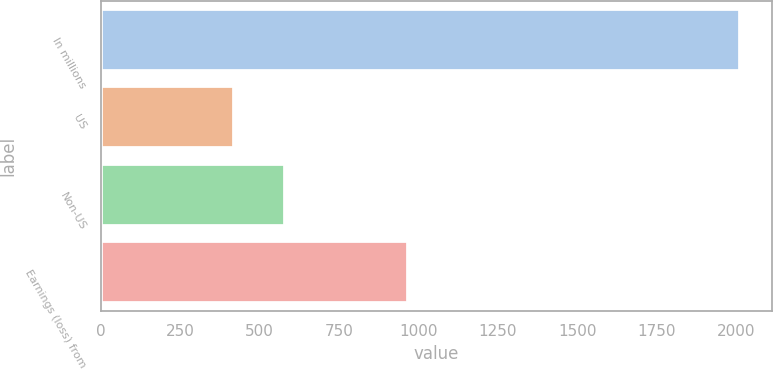Convert chart. <chart><loc_0><loc_0><loc_500><loc_500><bar_chart><fcel>In millions<fcel>US<fcel>Non-US<fcel>Earnings (loss) from<nl><fcel>2012<fcel>419<fcel>578.3<fcel>967<nl></chart> 